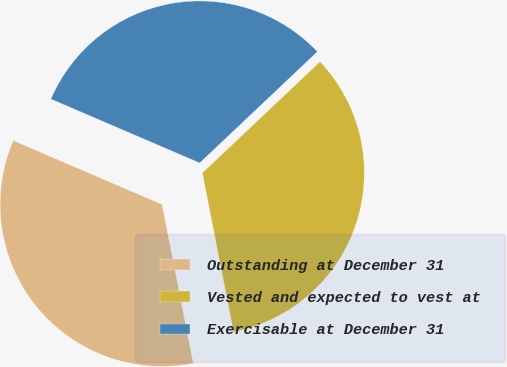Convert chart. <chart><loc_0><loc_0><loc_500><loc_500><pie_chart><fcel>Outstanding at December 31<fcel>Vested and expected to vest at<fcel>Exercisable at December 31<nl><fcel>34.54%<fcel>33.97%<fcel>31.49%<nl></chart> 